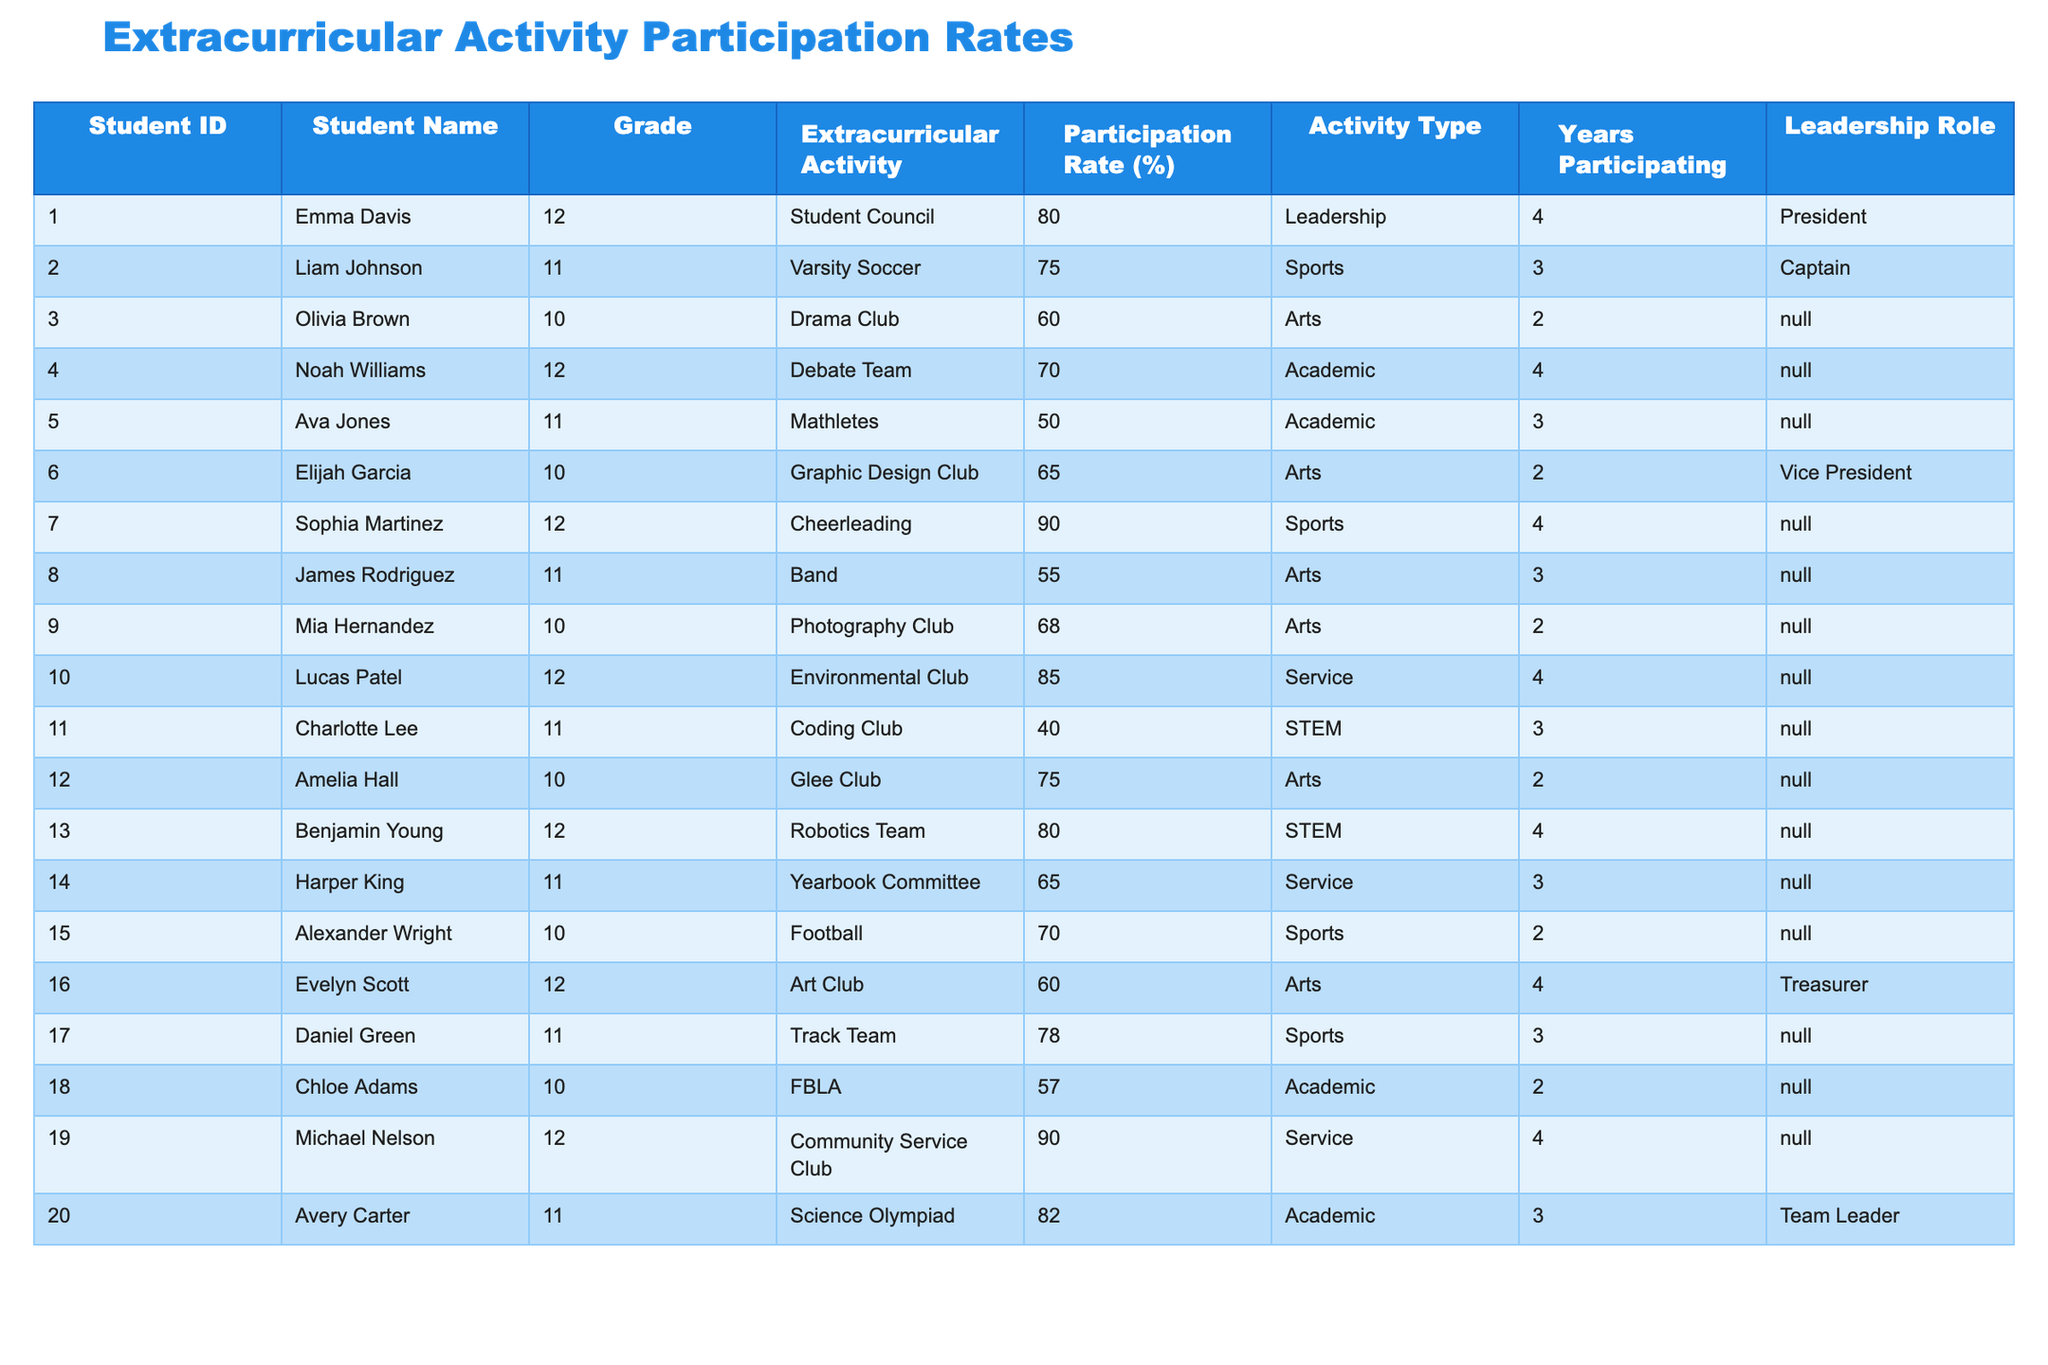What is the participation rate of the Student Council? Referring to the table, the Student Council has a participation rate of 80%.
Answer: 80% Which student has the highest participation rate? The table shows that both Sophia Martinez (Cheerleading) and Michael Nelson (Community Service Club) have the highest participation rates at 90%.
Answer: 90% How many students have a participation rate above 75%? By reviewing the participation rates, the students participating in Cheerleading, Community Service Club, Varsity Soccer, Environmental Club, and Science Olympiad have rates above 75%, totaling 5 students.
Answer: 5 What is the average participation rate of the sports activities? The participation rates for sports activities (Varsity Soccer, Cheerleading, Football, Track Team) are 75%, 90%, 70%, 78%. The average is (75 + 90 + 70 + 78) / 4 = 78.25%.
Answer: 78.25% Which student has been a part of extracurricular activities for the most years? The table lists the Years Participating, and both Emma Davis and Noah Williams have participated for 4 years.
Answer: 4 years Is there any student in the table who holds a leadership role but has a participation rate below 60%? A review of the table shows that the only leadership role below 60% is for Charlotte Lee in the Coding Club, who has a 40% participation rate.
Answer: Yes What is the total number of students participating in Academic activities? The Academic activities (Debate Team, Mathletes, FBLA, Science Olympiad) involve students; Noah Williams, Ava Jones, Chloe Adams, and Avery Carter, making a total of 4 students.
Answer: 4 Which type of activity has the highest average participation rate? Calculating the average participation rates: Sports average = (75 + 90 + 70 + 78) / 4 = 78.25%, Arts average = (60 + 65 + 55 + 68 + 75 + 60) / 6 = 62.5%, Academic average = (70 + 50 + 57 + 82) / 4 = 64.75%, Service average = (90 + 85 + 65) / 3 = 80%. Service has the highest average at 80%.
Answer: Service How many students have participated in extracurricular activities for less than 3 years? Analyzing the Years Participating, students who participated for less than 3 years are Olivia Brown, Ava Jones, Elijah Garcia, Mia Hernandez, Charlotte Lee, and Chloe Adams, totaling 6 students.
Answer: 6 What percentage of students are involved in STEM activities? From the table, 3 students are involved in STEM activities (Coding Club, Robotics Team) out of 20 students, so the percentage is (3/20) * 100 = 15%.
Answer: 15% 